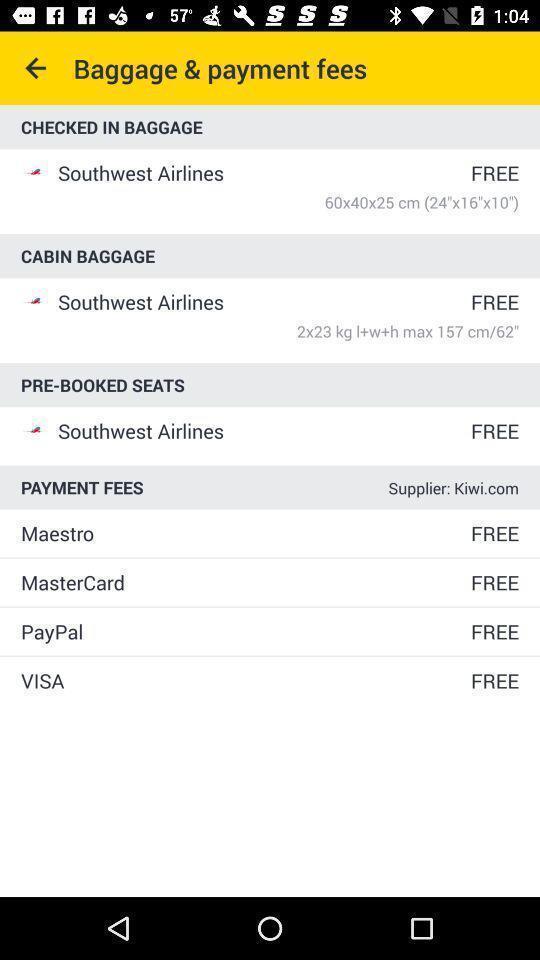Please provide a description for this image. Screen shows baggage payment fees option in flight application. 